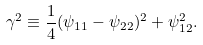<formula> <loc_0><loc_0><loc_500><loc_500>\gamma ^ { 2 } \equiv \frac { 1 } { 4 } ( \psi _ { 1 1 } - \psi _ { 2 2 } ) ^ { 2 } + \psi _ { 1 2 } ^ { 2 } .</formula> 